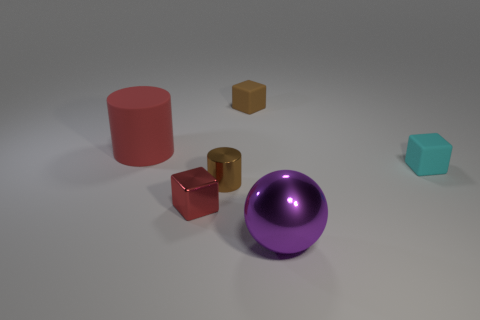Are there any other things that are the same shape as the large purple shiny object?
Offer a very short reply. No. There is a red object that is in front of the brown shiny cylinder; is it the same shape as the brown metal thing?
Give a very brief answer. No. Is the number of large things that are in front of the red metallic block greater than the number of large rubber things to the left of the big red rubber cylinder?
Keep it short and to the point. Yes. How many other objects are there of the same size as the cyan matte cube?
Give a very brief answer. 3. There is a cyan thing; is it the same shape as the large object that is in front of the cyan matte object?
Provide a short and direct response. No. What number of rubber objects are green cubes or large purple spheres?
Provide a succinct answer. 0. Is there a matte cylinder that has the same color as the tiny shiny block?
Give a very brief answer. Yes. Is there a small object?
Provide a succinct answer. Yes. Do the small red object and the red rubber object have the same shape?
Make the answer very short. No. What number of small objects are either matte cylinders or red things?
Make the answer very short. 1. 